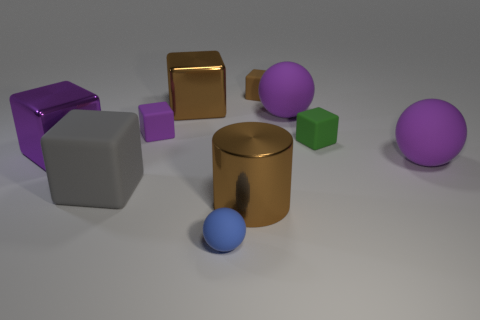How many purple cubes must be subtracted to get 1 purple cubes? 1 Subtract all green blocks. How many blocks are left? 5 Subtract all big rubber cubes. How many cubes are left? 5 Subtract all yellow blocks. Subtract all cyan cylinders. How many blocks are left? 6 Subtract all balls. How many objects are left? 7 Subtract 0 yellow spheres. How many objects are left? 10 Subtract all small rubber objects. Subtract all small purple matte cubes. How many objects are left? 5 Add 1 big cubes. How many big cubes are left? 4 Add 2 spheres. How many spheres exist? 5 